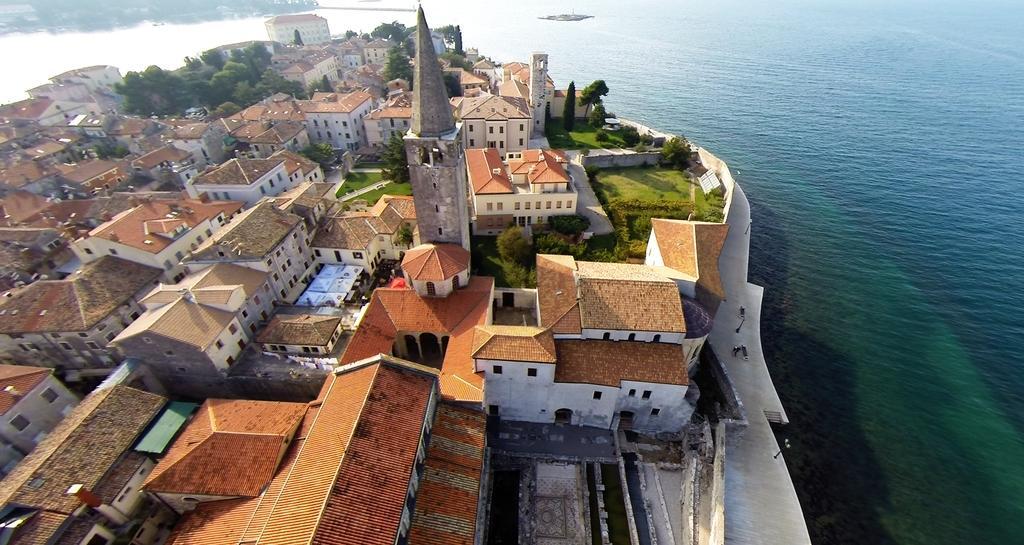In one or two sentences, can you explain what this image depicts? In this picture we can see water, buildings, grass and trees. 